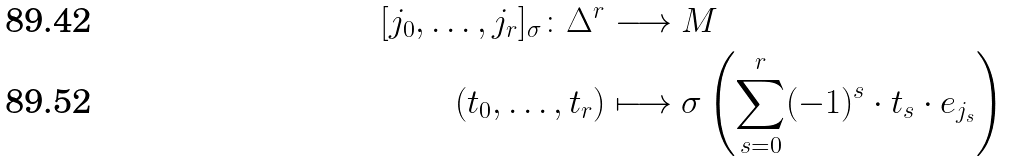Convert formula to latex. <formula><loc_0><loc_0><loc_500><loc_500>[ j _ { 0 } , \dots , j _ { r } ] _ { \sigma } \colon \Delta ^ { r } & \longrightarrow M \\ ( t _ { 0 } , \dots , t _ { r } ) & \longmapsto \sigma \left ( \sum _ { s = 0 } ^ { r } ( - 1 ) ^ { s } \cdot t _ { s } \cdot e _ { j _ { s } } \right )</formula> 